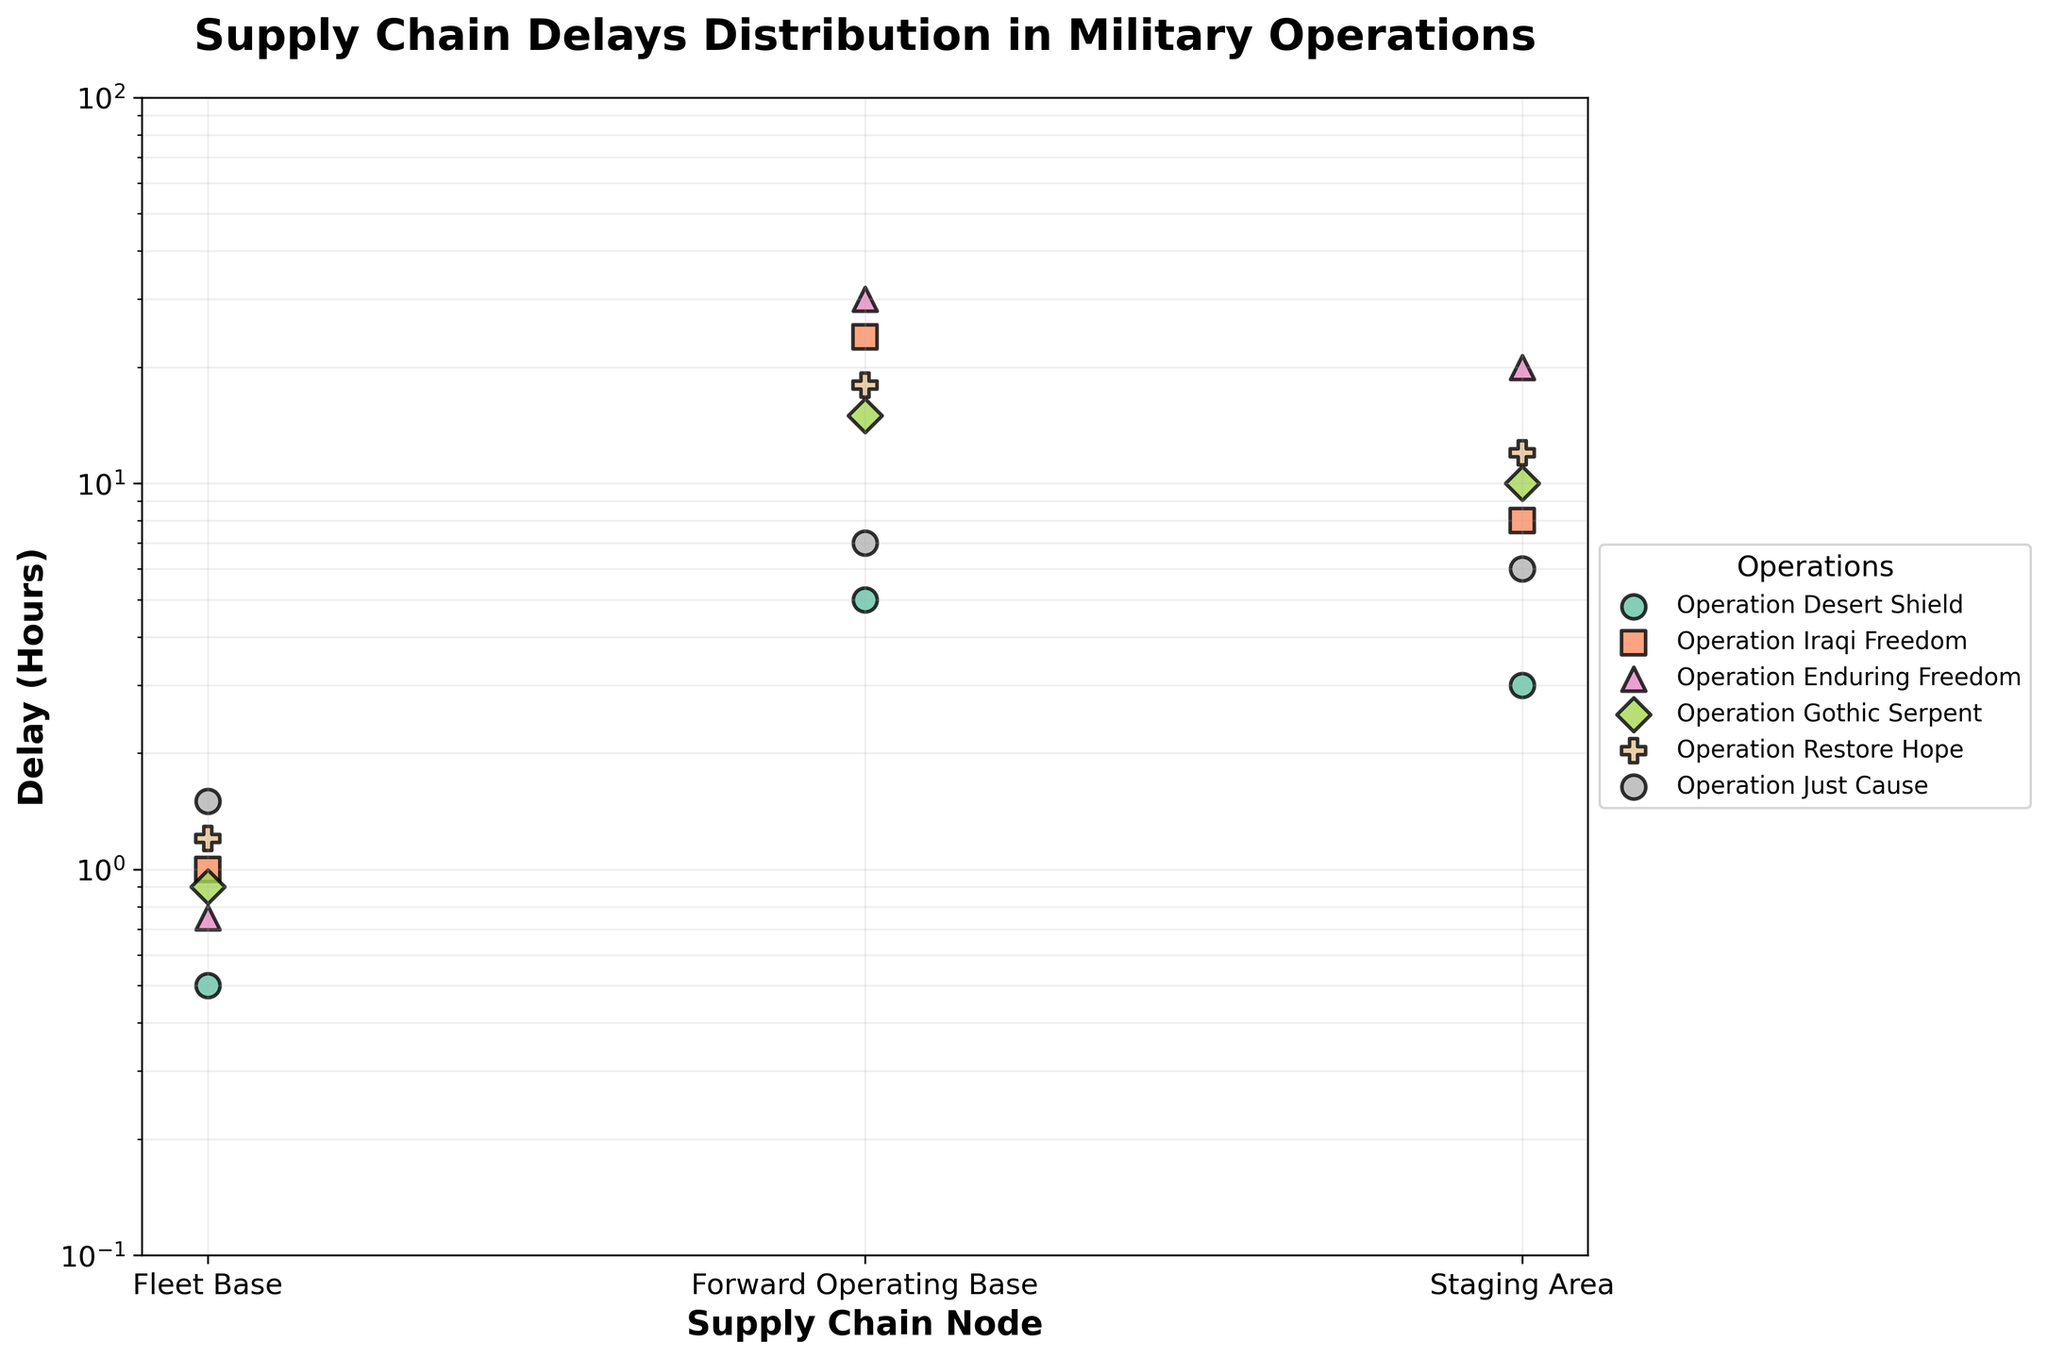What's the title of the figure? The title is usually located at the top center of the plot and provides a summary of what the plot is about. By examining the figure, we can see the title given.
Answer: Supply Chain Delays Distribution in Military Operations How many different military operations are depicted in the figure? Different operations are often represented by different colors or markers. By counting distinct colors or markers in the legend, we can determine the number of operations.
Answer: 6 Which supply chain node has the highest average delay across all operations? To find this, we need to look at each node category and calculate the average delay time from the figures given for each operation, then compare these averages.
Answer: Forward Operating Base Which operation shows the smallest delay at the Fleet Base node? By looking at the Fleet Base node for each operation, we compare the delay times to see which is the smallest. The smallest delay in this case is easy to identify on the log scale as the value closest to the bottom of the axis.
Answer: Operation Desert Shield How does the delay at the Staging Area node in Operation Enduring Freedom compare to that in Operation Restore Hope? To compare these two data points, examine their positions on the y-axis for the Staging Area under these specific operations. Check which point is higher to determine the greater delay.
Answer: The delay in Operation Enduring Freedom is greater than in Operation Restore Hope Which node exhibits the greatest variation in delays across different operations? This involves a bit more analysis. We check the range of delays (difference between maximum and minimum) for each node across all operations. The node with the largest range indicates the greatest variation.
Answer: Forward Operating Base Between Operation Iraqi Freedom and Operation Gothic Serpent, which operation has a higher delay at the Forward Operating Base node? We compare the delay times at the Forward Operating Base node for Operation Iraqi Freedom and Operation Gothic Serpent by checking their positions on the y-axis.
Answer: Operation Iraqi Freedom What's the median delay at the Fleet Base node across all operations? To find the median delay, list the Fleet Base delays for all operations in numerical order and find the middle value.
Answer: 0.9 For Operation Desert Shield, if the delays at all nodes were made equal to the average of their current delays, what would this value be? To find the average delay for Operation Desert Shield, sum its delays (0.5 + 5 + 3) and divide by the number of nodes (3). 0.5 + 5 + 3 = 8.5, so the average delay will be 8.5 / 3.
Answer: 2.83 